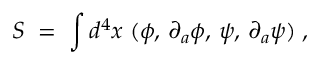<formula> <loc_0><loc_0><loc_500><loc_500>S \, = \, \int d ^ { 4 } x \, \L ( \phi , \, \partial _ { a } \phi , \, \psi , \, \partial _ { a } \psi ) \, ,</formula> 